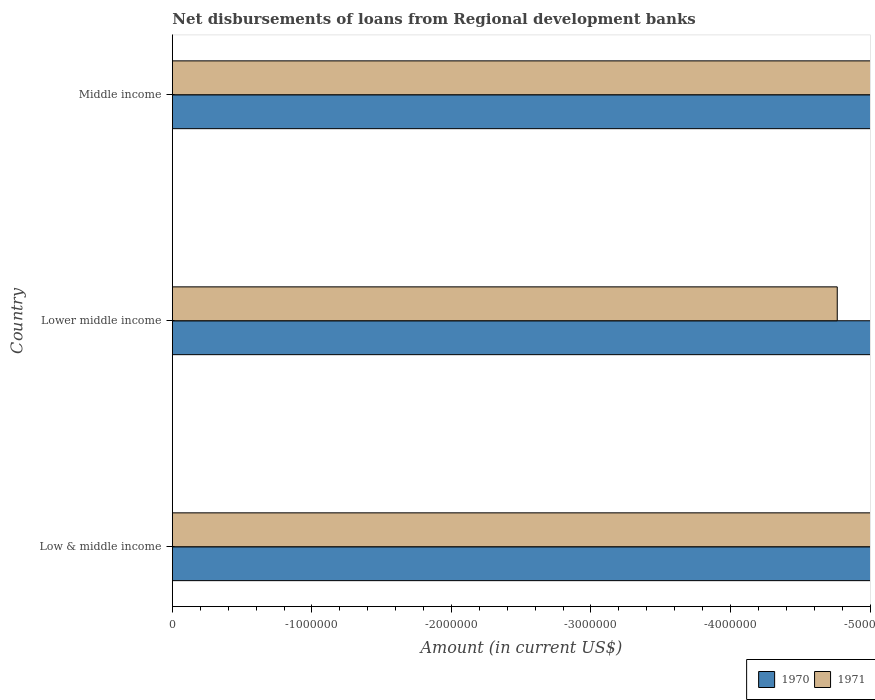Are the number of bars on each tick of the Y-axis equal?
Make the answer very short. Yes. How many bars are there on the 2nd tick from the bottom?
Give a very brief answer. 0. What is the label of the 2nd group of bars from the top?
Keep it short and to the point. Lower middle income. In how many cases, is the number of bars for a given country not equal to the number of legend labels?
Your answer should be compact. 3. What is the amount of disbursements of loans from regional development banks in 1971 in Low & middle income?
Provide a short and direct response. 0. Across all countries, what is the minimum amount of disbursements of loans from regional development banks in 1970?
Ensure brevity in your answer.  0. What is the total amount of disbursements of loans from regional development banks in 1971 in the graph?
Offer a very short reply. 0. In how many countries, is the amount of disbursements of loans from regional development banks in 1970 greater than the average amount of disbursements of loans from regional development banks in 1970 taken over all countries?
Your response must be concise. 0. How many bars are there?
Your answer should be very brief. 0. How many countries are there in the graph?
Offer a terse response. 3. What is the difference between two consecutive major ticks on the X-axis?
Offer a very short reply. 1.00e+06. Does the graph contain any zero values?
Your answer should be very brief. Yes. Does the graph contain grids?
Your answer should be compact. No. How many legend labels are there?
Ensure brevity in your answer.  2. What is the title of the graph?
Ensure brevity in your answer.  Net disbursements of loans from Regional development banks. What is the Amount (in current US$) in 1970 in Low & middle income?
Your response must be concise. 0. What is the Amount (in current US$) of 1971 in Lower middle income?
Provide a succinct answer. 0. What is the Amount (in current US$) in 1970 in Middle income?
Offer a terse response. 0. What is the average Amount (in current US$) in 1970 per country?
Your answer should be very brief. 0. What is the average Amount (in current US$) of 1971 per country?
Your answer should be compact. 0. 